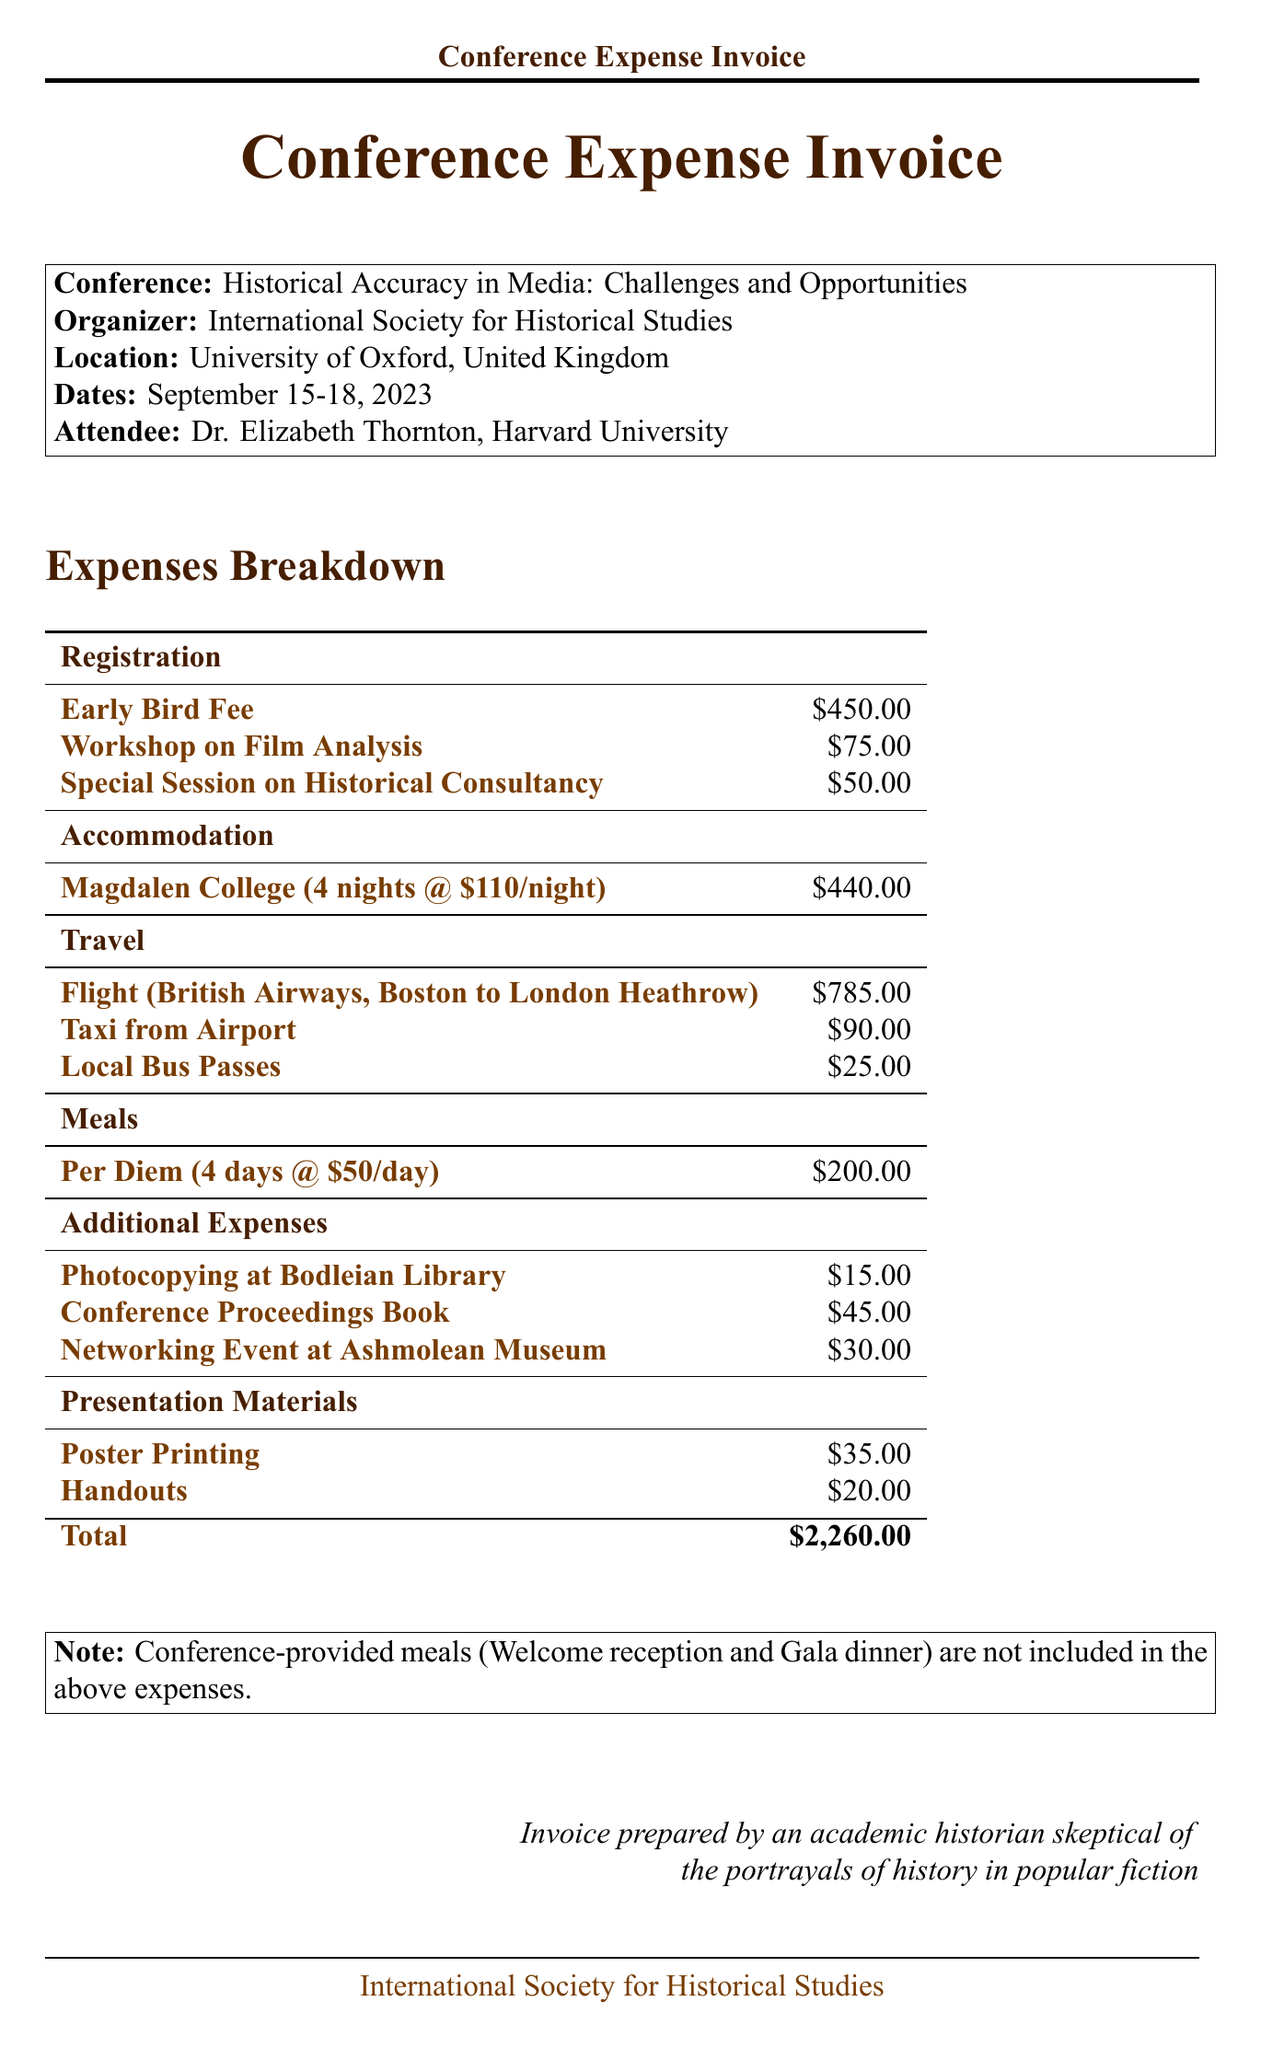What is the conference name? The conference name is prominently displayed at the top of the document.
Answer: Historical Accuracy in Media: Challenges and Opportunities Who organized the conference? The organizer's name is given in the document under the conference details.
Answer: International Society for Historical Studies How many nights of accommodation were provided? The number of nights for accommodation is specified in the accommodation section.
Answer: 4 What is the total travel cost? To find this, add the flight, taxi, and local bus costs, which are listed under travel expenses.
Answer: $900.00 What is the per diem rate? The per diem rate is mentioned in the meals section of the document.
Answer: $50.00 How much was spent on presentation materials? This is found by summing the costs of both poster printing and handouts listed under presentation materials.
Answer: $55.00 What is the total amount of the invoice? The total amount is listed at the bottom and is the sum of all expenses.
Answer: $2,260.00 What is the venue for accommodation? The venue name is specifically mentioned in the accommodation section.
Answer: Magdalen College What meals were provided by the conference? The meals provided are listed in the meals section of the document.
Answer: Welcome reception, Gala dinner 